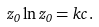Convert formula to latex. <formula><loc_0><loc_0><loc_500><loc_500>z _ { 0 } \ln z _ { 0 } = k c \, .</formula> 